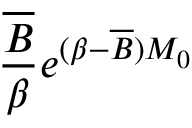<formula> <loc_0><loc_0><loc_500><loc_500>\frac { \overline { B } } { \beta } e ^ { ( \beta - \overline { B } ) M _ { 0 } }</formula> 